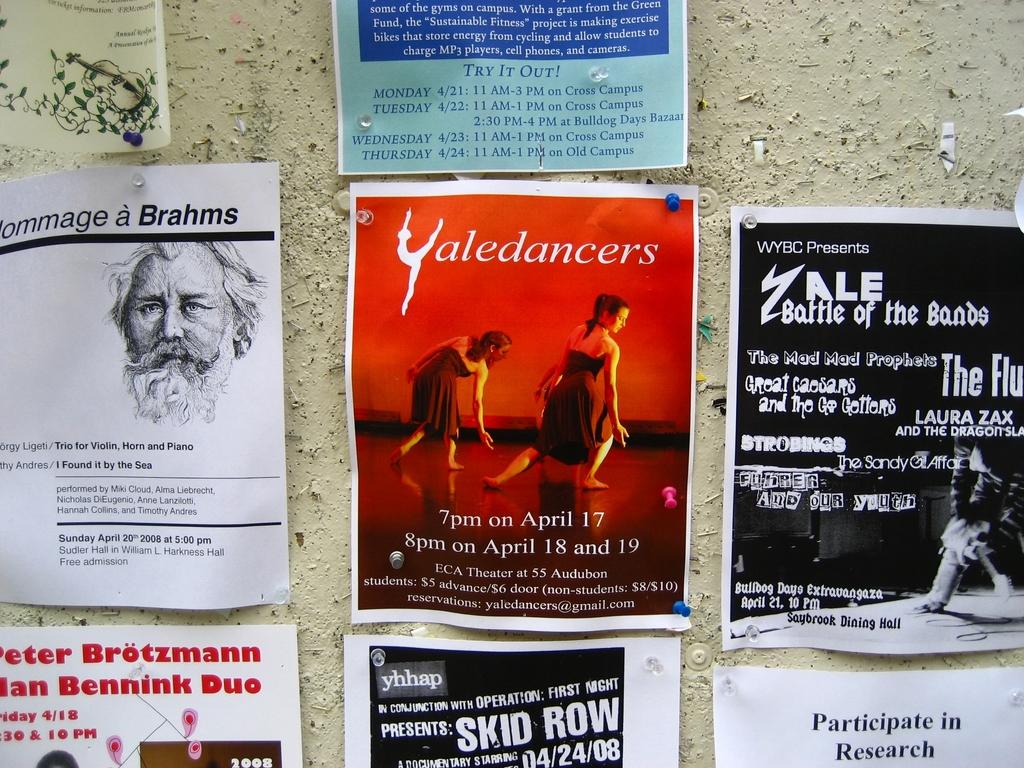In what month do the yaledancers perform?
Offer a terse response. April. Who is presenting the yale battle of the bands?
Ensure brevity in your answer.  Wybc. 